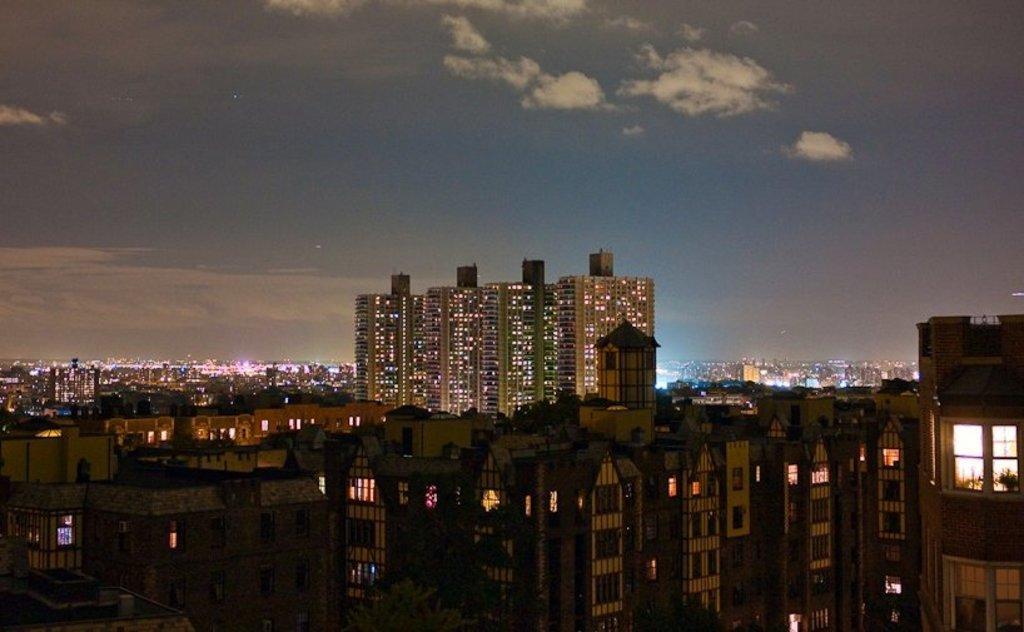Describe this image in one or two sentences. In the foreground of this picture, there are buildings. In the background, we can see the city. On the top, there is the sky and the cloud. 